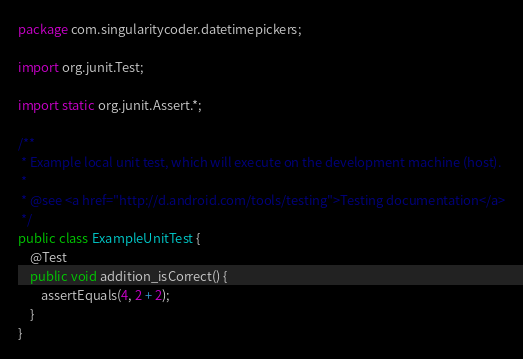Convert code to text. <code><loc_0><loc_0><loc_500><loc_500><_Java_>package com.singularitycoder.datetimepickers;

import org.junit.Test;

import static org.junit.Assert.*;

/**
 * Example local unit test, which will execute on the development machine (host).
 *
 * @see <a href="http://d.android.com/tools/testing">Testing documentation</a>
 */
public class ExampleUnitTest {
    @Test
    public void addition_isCorrect() {
        assertEquals(4, 2 + 2);
    }
}</code> 